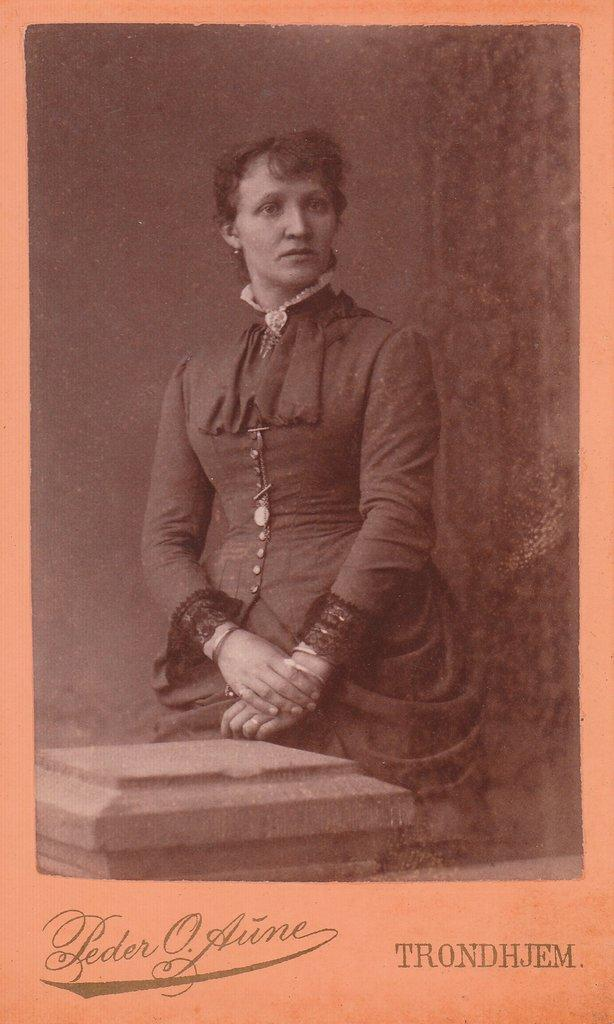Who is the main subject in the foreground of the poster? There is a lady standing in the foreground of the poster. What can be found at the bottom of the poster? There is text at the bottom of the poster. What is visible in the background of the poster? It appears to be a wall in the background of the poster. Where is the zoo located in the poster? There is no zoo present in the poster. What type of education is being promoted in the poster? The poster does not specifically promote any type of education; it features a lady standing in the foreground and text at the bottom. 